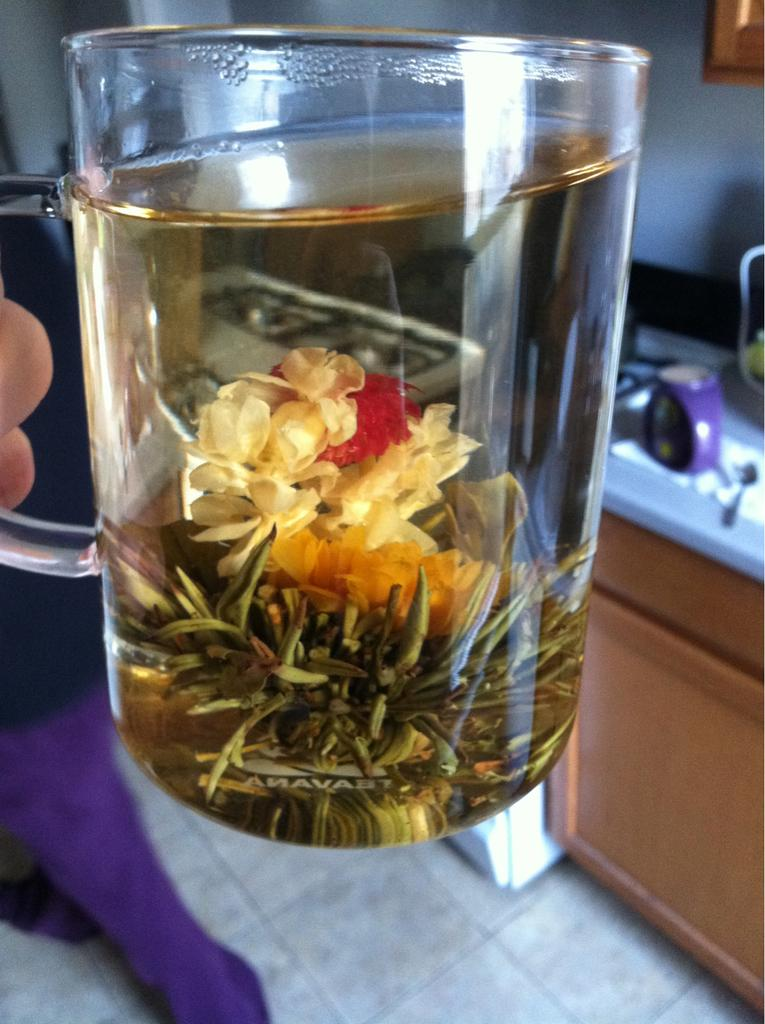What is in the glass that is visible in the image? The glass contains water. Are there any other items in the glass besides water? Yes, there are other objects in the glass. What can be seen in the background of the image? There are other objects visible in the background of the image. What type of instrument is being played in the background of the image? There is no instrument being played in the background of the image. Can you tell me which attraction is visible in the background of the image? There is no attraction visible in the background of the image. 